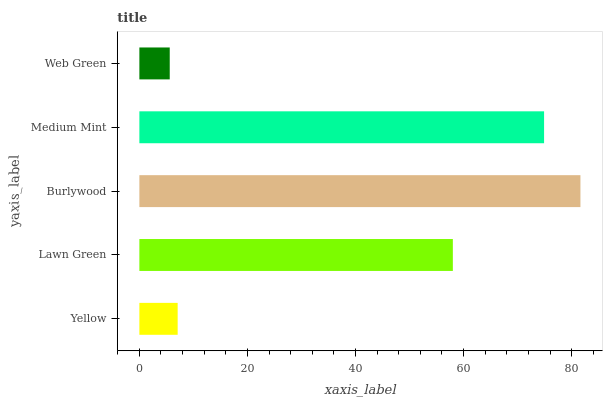Is Web Green the minimum?
Answer yes or no. Yes. Is Burlywood the maximum?
Answer yes or no. Yes. Is Lawn Green the minimum?
Answer yes or no. No. Is Lawn Green the maximum?
Answer yes or no. No. Is Lawn Green greater than Yellow?
Answer yes or no. Yes. Is Yellow less than Lawn Green?
Answer yes or no. Yes. Is Yellow greater than Lawn Green?
Answer yes or no. No. Is Lawn Green less than Yellow?
Answer yes or no. No. Is Lawn Green the high median?
Answer yes or no. Yes. Is Lawn Green the low median?
Answer yes or no. Yes. Is Web Green the high median?
Answer yes or no. No. Is Burlywood the low median?
Answer yes or no. No. 